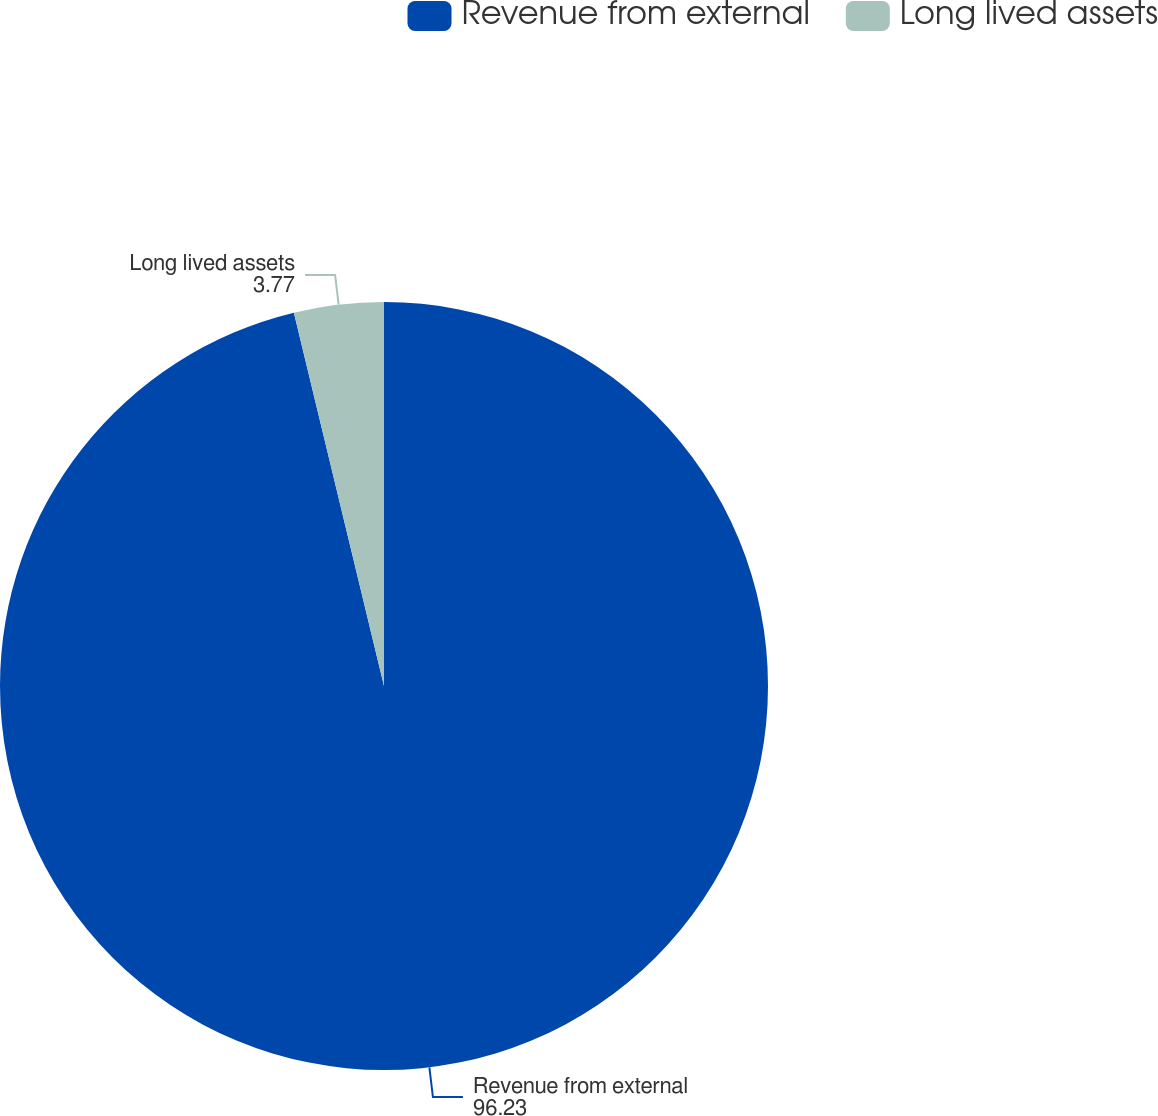Convert chart to OTSL. <chart><loc_0><loc_0><loc_500><loc_500><pie_chart><fcel>Revenue from external<fcel>Long lived assets<nl><fcel>96.23%<fcel>3.77%<nl></chart> 